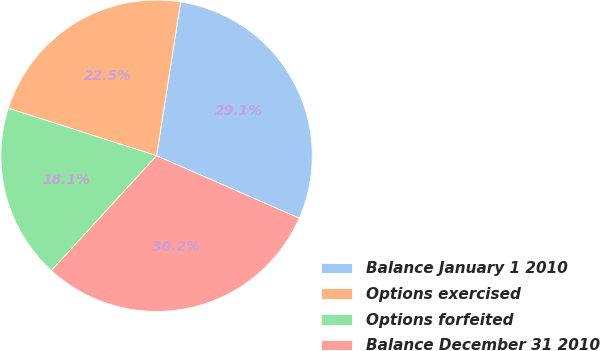Convert chart to OTSL. <chart><loc_0><loc_0><loc_500><loc_500><pie_chart><fcel>Balance January 1 2010<fcel>Options exercised<fcel>Options forfeited<fcel>Balance December 31 2010<nl><fcel>29.1%<fcel>22.53%<fcel>18.13%<fcel>30.24%<nl></chart> 